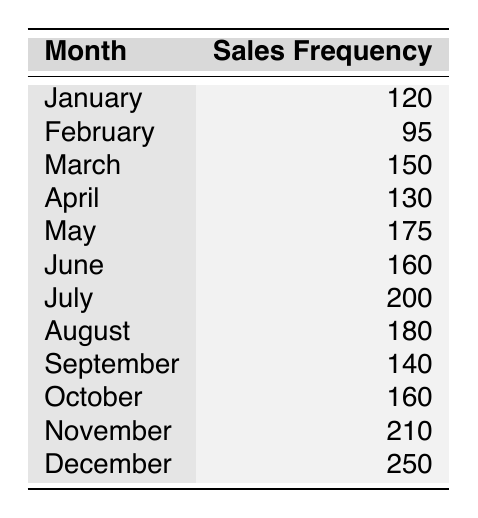What is the month with the highest sales frequency? From the table, December has the highest sales frequency listed as 250.
Answer: December What is the sales frequency for July? The table directly states that the sales frequency for July is 200.
Answer: 200 Which month had the lowest sales frequency? By comparing all the sales frequencies listed, February has the lowest value at 95.
Answer: February What is the total sales frequency from May to November? The sales from May to November are: 175 (May), 160 (June), 200 (July), 180 (August), 140 (September), 160 (October), 210 (November). Adding these gives: 175 + 160 + 200 + 180 + 140 + 160 + 210 = 1125.
Answer: 1125 What is the average sales frequency for the first half of the year? The months from January to June are: January (120), February (95), March (150), April (130), May (175), June (160). The total sales for these months is 120 + 95 + 150 + 130 + 175 + 160 = 930. There are 6 months, so the average is 930/6 = 155.
Answer: 155 Did sales frequency increase every month from January to July? Checking the sales frequencies: January (120), February (95), March (150), April (130), May (175), June (160), July (200). The sales frequency decreased from January to February, so it did not increase every month.
Answer: No Which month saw an increase in sales when comparing it to the previous month? By checking each month against the previous month, we find these months had increases: March (compared to February), April (compared to March), May (compared to April), June (compared to May), July (compared to June), August (compared to July), October (compared to September), November (compared to October), December (compared to November).
Answer: March, April, May, June, July, August, October, November, December What is the difference in sales frequency between November and January? November sales are 210, January sales are 120. The difference is: 210 - 120 = 90.
Answer: 90 What percentage of total yearly sales occurred in December? Total sales for the year = 120 + 95 + 150 + 130 + 175 + 160 + 200 + 180 + 140 + 160 + 210 + 250 = 2070. December sales are 250. Therefore, the percentage for December is (250/2070) * 100 ≈ 12.08%.
Answer: 12.08% 